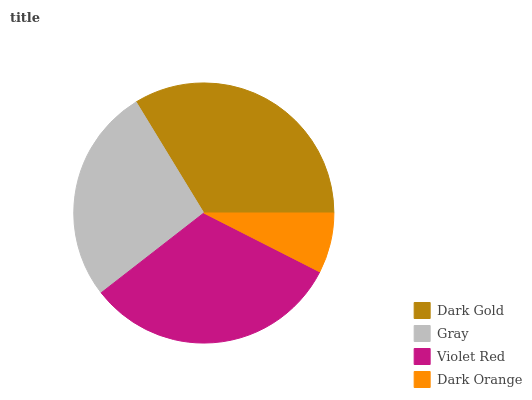Is Dark Orange the minimum?
Answer yes or no. Yes. Is Dark Gold the maximum?
Answer yes or no. Yes. Is Gray the minimum?
Answer yes or no. No. Is Gray the maximum?
Answer yes or no. No. Is Dark Gold greater than Gray?
Answer yes or no. Yes. Is Gray less than Dark Gold?
Answer yes or no. Yes. Is Gray greater than Dark Gold?
Answer yes or no. No. Is Dark Gold less than Gray?
Answer yes or no. No. Is Violet Red the high median?
Answer yes or no. Yes. Is Gray the low median?
Answer yes or no. Yes. Is Dark Gold the high median?
Answer yes or no. No. Is Dark Gold the low median?
Answer yes or no. No. 